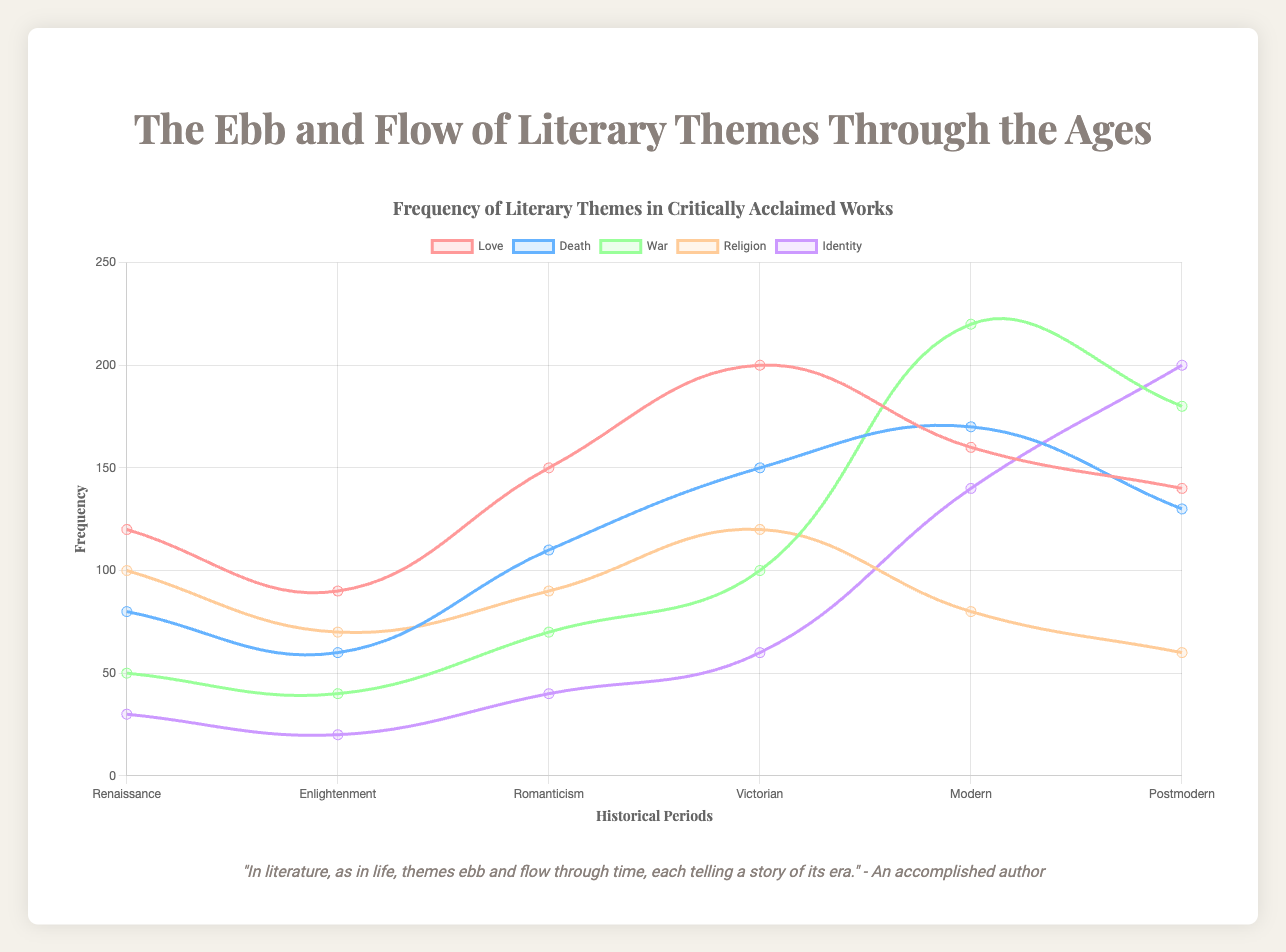What is the most frequently occurring theme in the Victorian period? Observing the highest point on the Victorian period across different themes, 'Love' stands out with a frequency of 200.
Answer: Love Which historical period has the lowest frequency of the 'Religion' theme? By examining the 'Religion' theme curve across different historical periods, we find the lowest point occurs in the Postmodern period with a frequency of 60.
Answer: Postmodern How many times does the frequency of the 'War' theme increase from the Enlightenment period to the Modern period? The frequency of the 'War' theme in the Enlightenment period is 40, and in the Modern period, it is 220. The increase is calculated as 220 - 40 = 180.
Answer: 180 Average the frequency of the 'Identity' theme during Romanticism, Victorian, and Modern periods? The frequencies are 40 (Romanticism), 60 (Victorian), and 140 (Modern). The average is (40 + 60 + 140) / 3 = 240 / 3 = 80.
Answer: 80 Which theme in the Modern period has the highest frequency, and what is it? Among the themes in the Modern period, 'War' has the highest frequency of 220.
Answer: War, 220 In which period does the 'Death' theme surpass the 'Love' theme in frequency? By comparing the frequencies of 'Death' and 'Love' in each period, we find the 'Death' theme only surpasses the 'Love' theme in the Modern period (Death: 170, Love: 160).
Answer: Modern Compare the themes of 'Identity' and 'War' in the Postmodern period. Which theme appears more frequently? In the Postmodern period, the frequency for 'Identity' is 200 and for 'War' is 180. 'Identity' appears more frequently.
Answer: Identity Which theme shows a decreasing trend in frequency from the Victorian to the Postmodern periods? The 'Religion' theme shows a decreasing trend from Victorian (120) to Postmodern (60).
Answer: Religion Summarize the change in frequency for the 'Love' theme from the Renaissance to the Postmodern period. The 'Love' theme changes through these frequencies: Renaissance (120), Enlightenment (90), Romanticism (150), Victorian (200), Modern (160), Postmodern (140), showing initial increase, peak at Victorian, and then a gradual decline.
Answer: Initial increase, peak at Victorian, gradual decline 